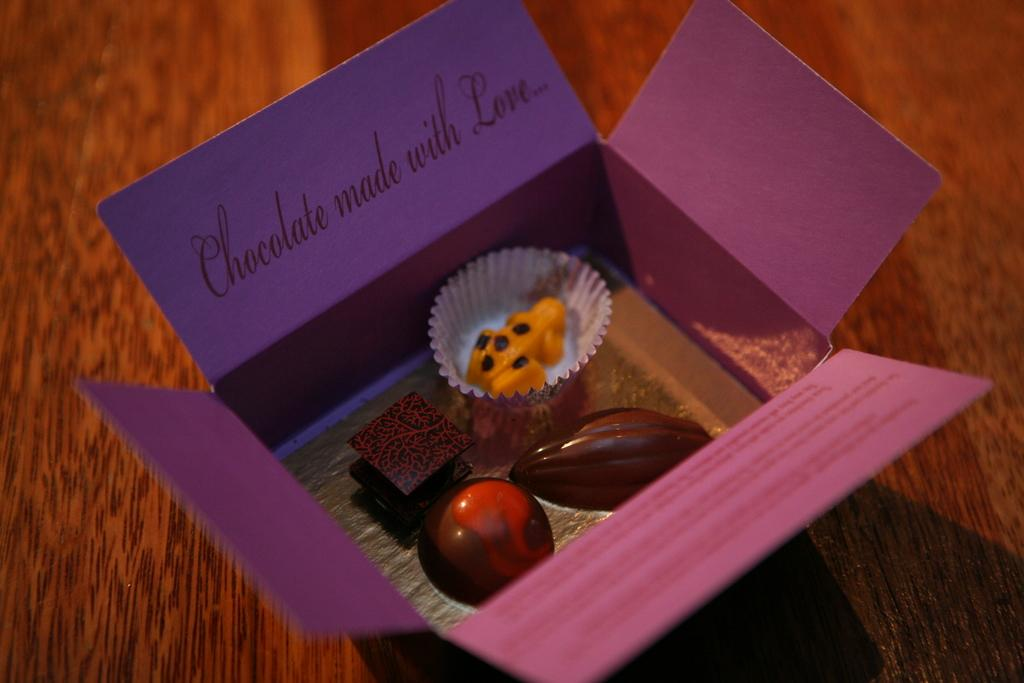What type of confectionery can be seen in the image? There are chocolates of different structures in the image. How are the chocolates packaged? The chocolates are kept in a square paper box. On what surface is the box placed? The box is placed on a wooden table. What type of dust can be seen on the chocolates in the image? There is no dust visible on the chocolates in the image. 